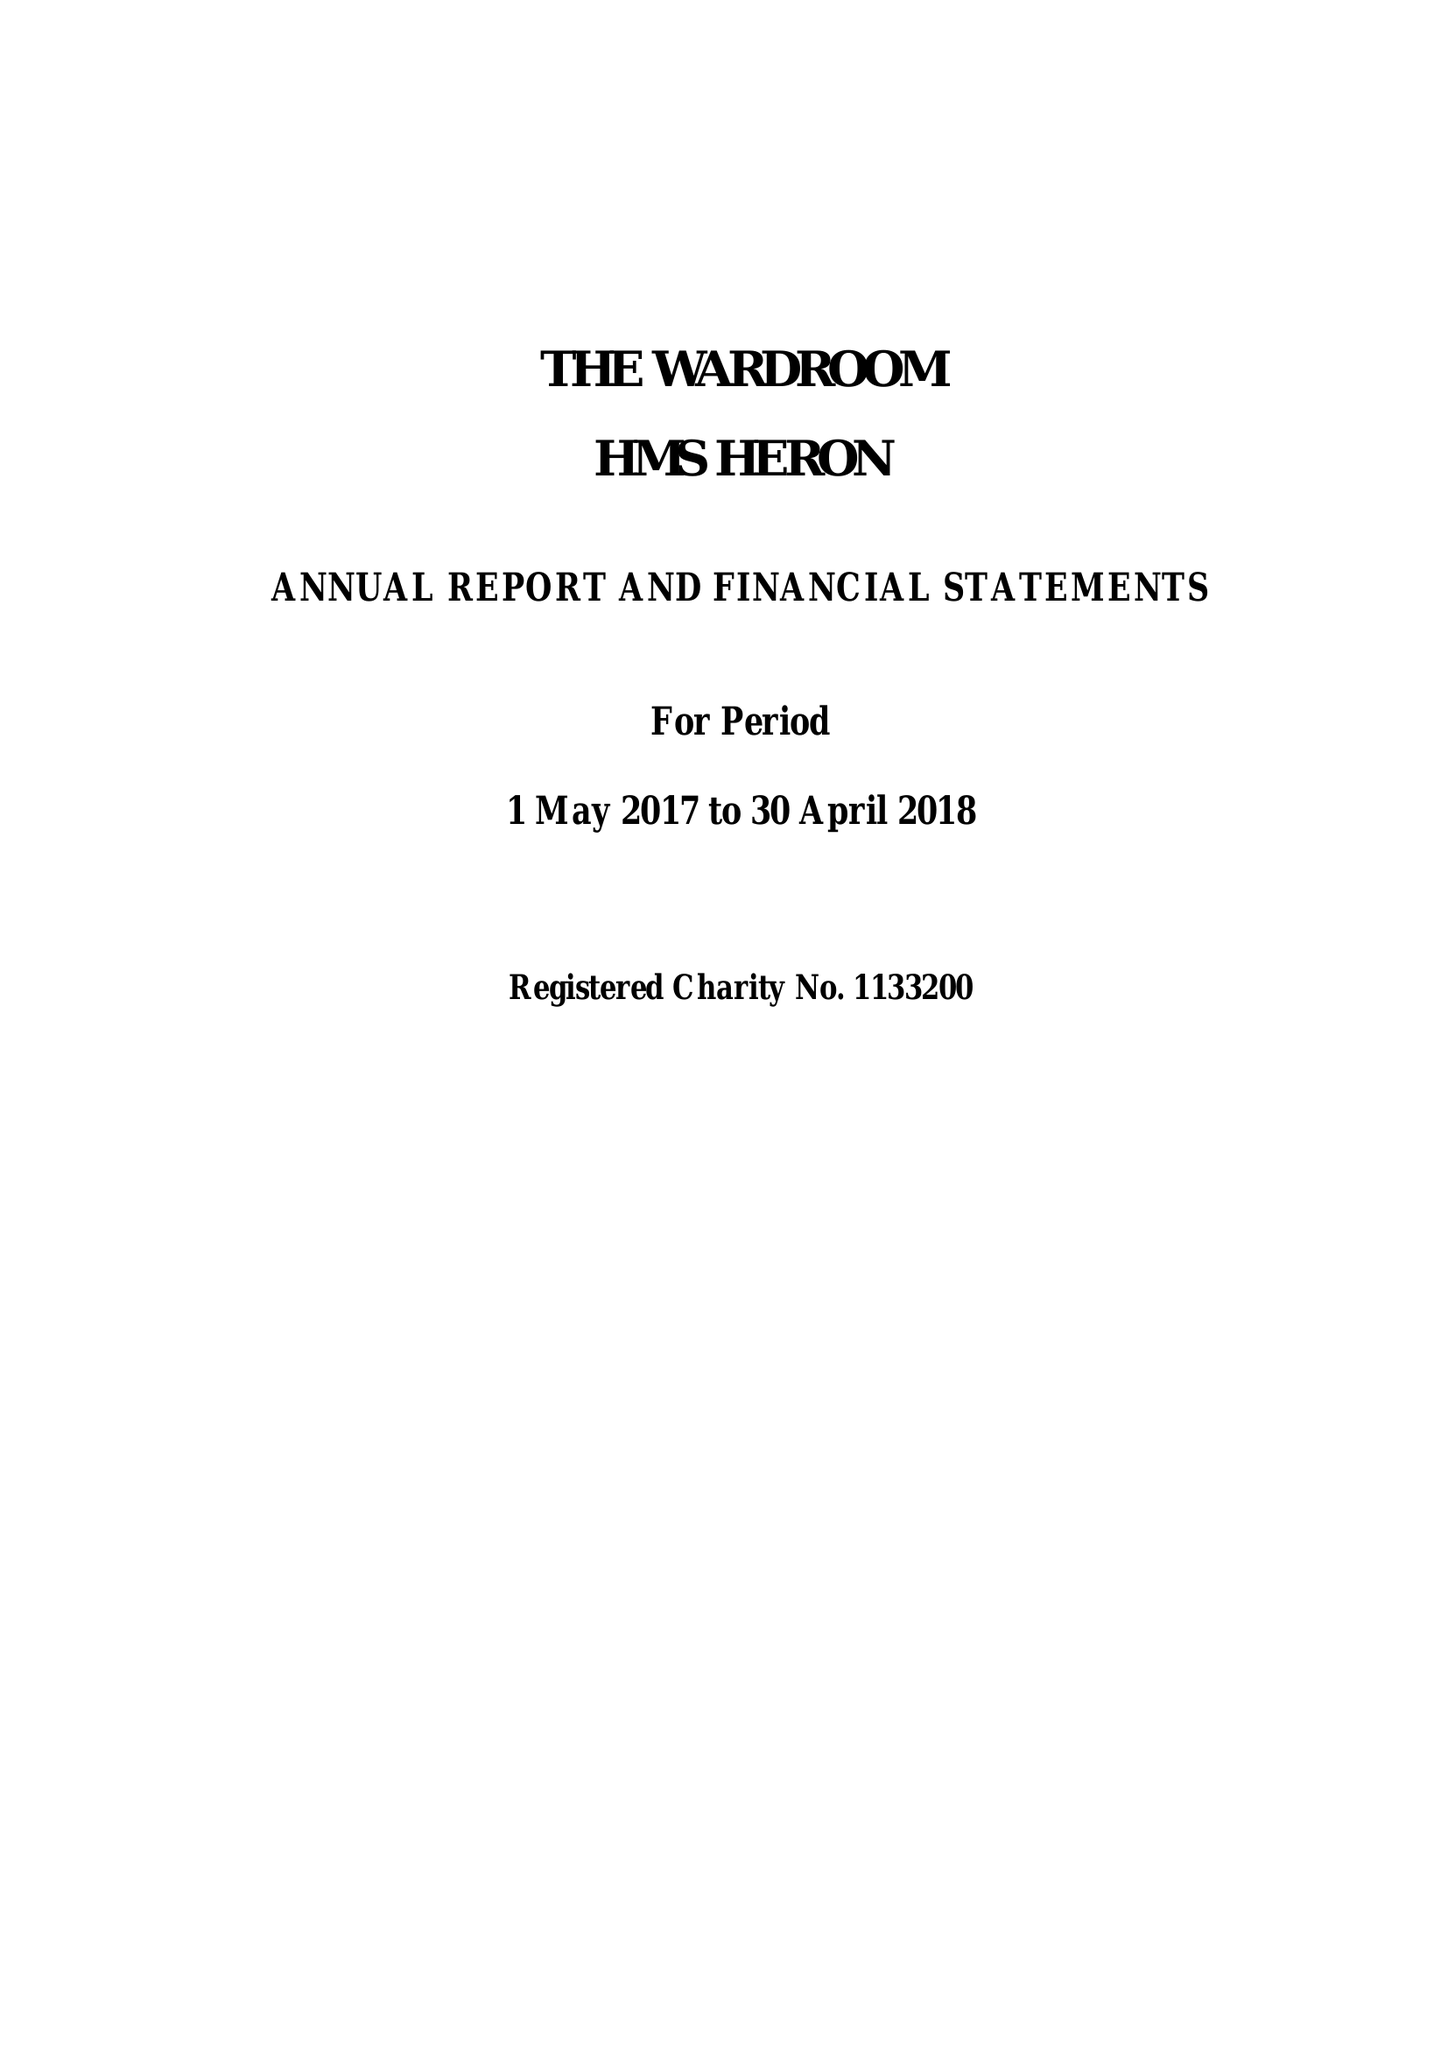What is the value for the address__street_line?
Answer the question using a single word or phrase. YEOVILTON 